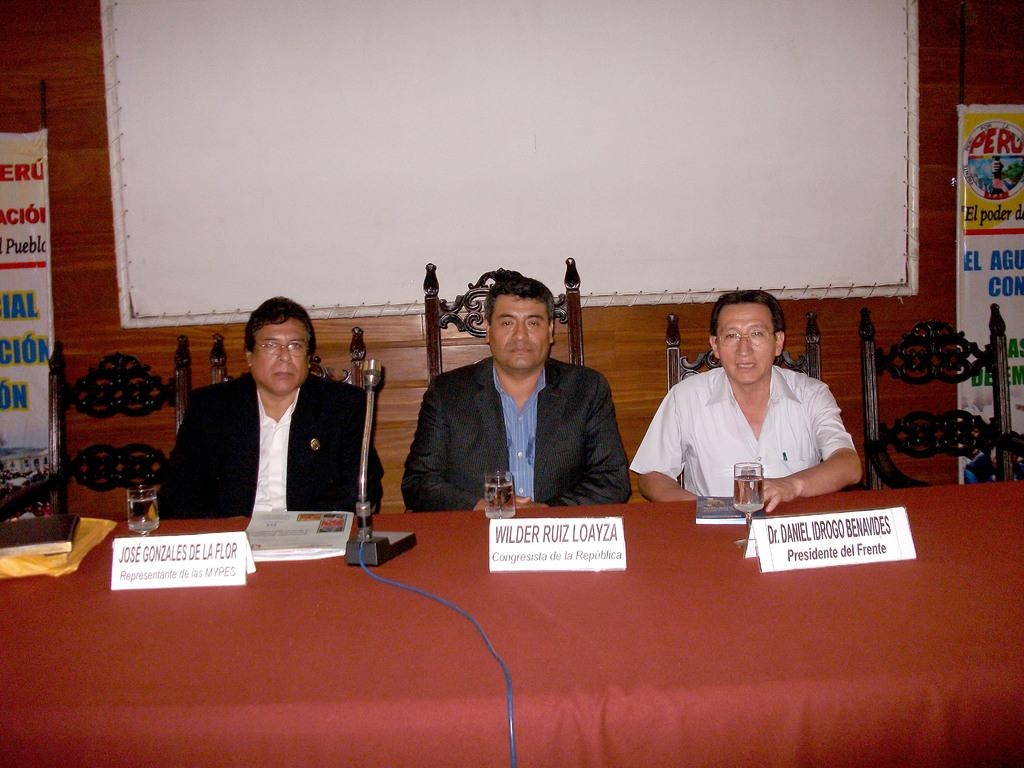<image>
Summarize the visual content of the image. The men sitting at a table with the middle mans's name being Wilder Ruiz Loayza. 